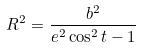Convert formula to latex. <formula><loc_0><loc_0><loc_500><loc_500>R ^ { 2 } = \frac { b ^ { 2 } } { e ^ { 2 } \cos ^ { 2 } t - 1 }</formula> 